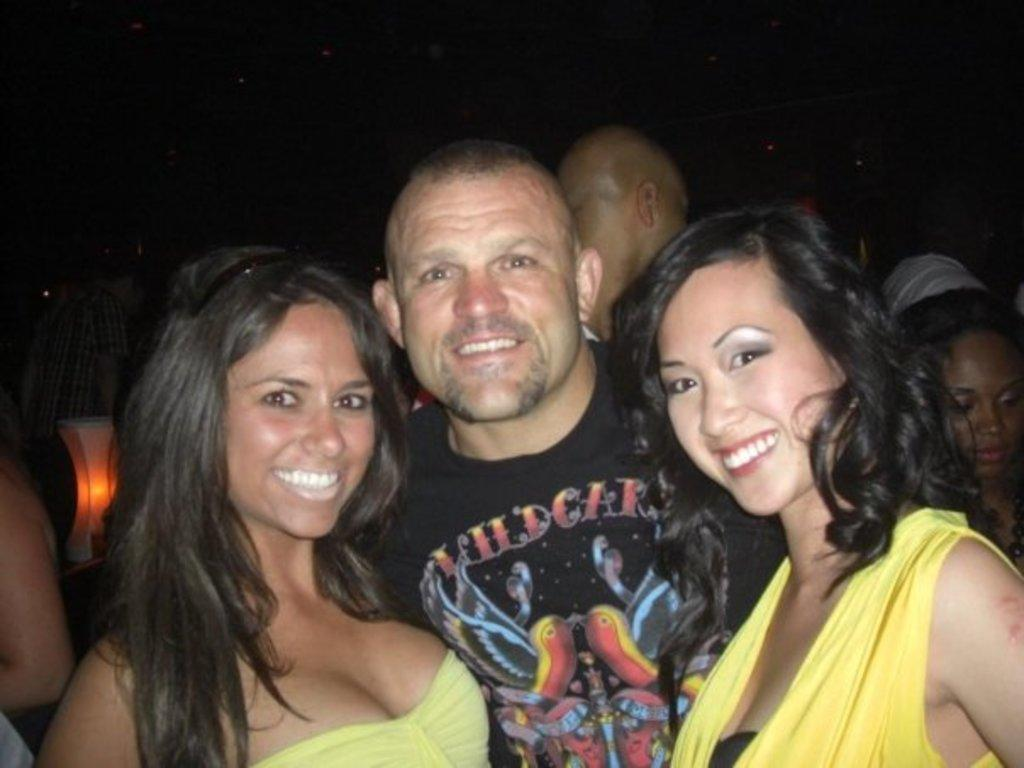How many people are in the image? There are three persons in the image. What are the expressions on the faces of the persons in the image? The persons in the image are smiling. Can you describe the object in the image? Unfortunately, the facts provided do not give any details about the object in the image. What is the nature of the group of people in the image? The group of people in the image consists of three persons who are standing together. What is the color of the background in the image? The background of the image is dark. Can you tell me how many knees are visible in the image? There is no information about knees in the provided facts, so we cannot determine how many are visible in the image. 